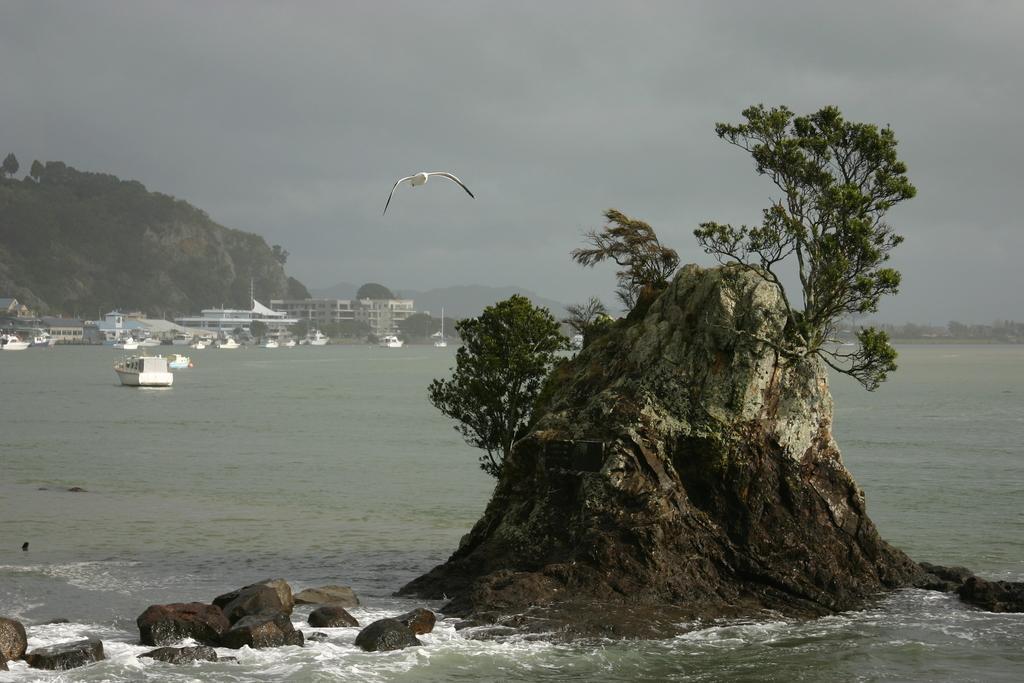Describe this image in one or two sentences. In this image we can see there is the bird flying. And there is the rock with trees on the water. And there are ships, buildings, trees, mountains and the sky. 